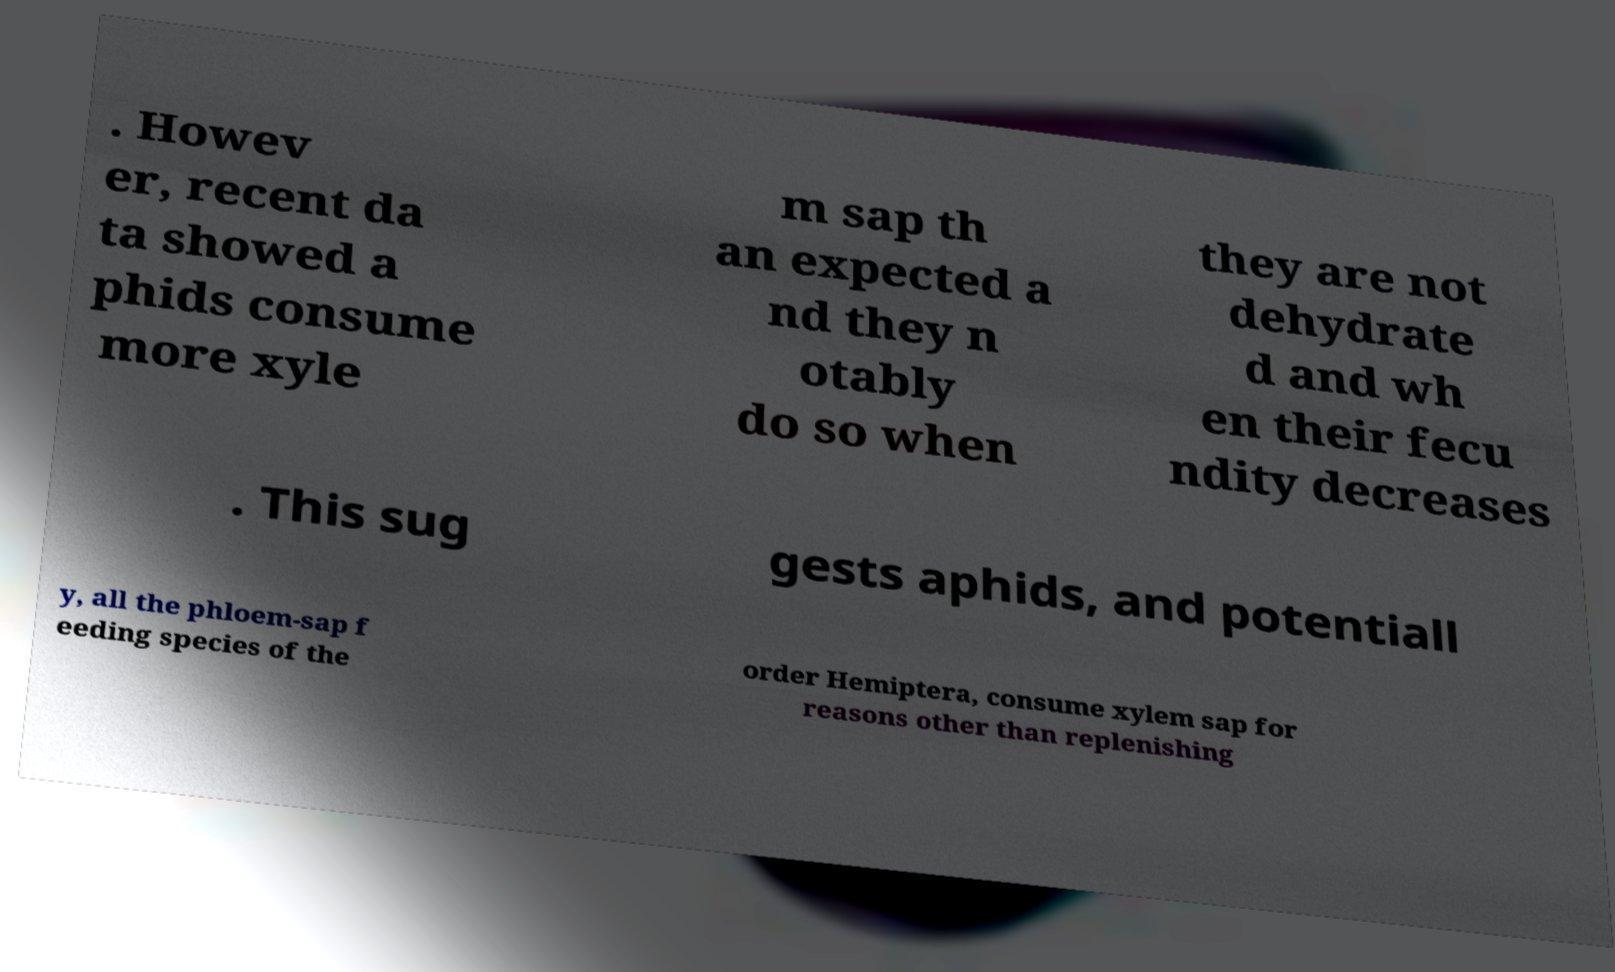I need the written content from this picture converted into text. Can you do that? . Howev er, recent da ta showed a phids consume more xyle m sap th an expected a nd they n otably do so when they are not dehydrate d and wh en their fecu ndity decreases . This sug gests aphids, and potentiall y, all the phloem-sap f eeding species of the order Hemiptera, consume xylem sap for reasons other than replenishing 